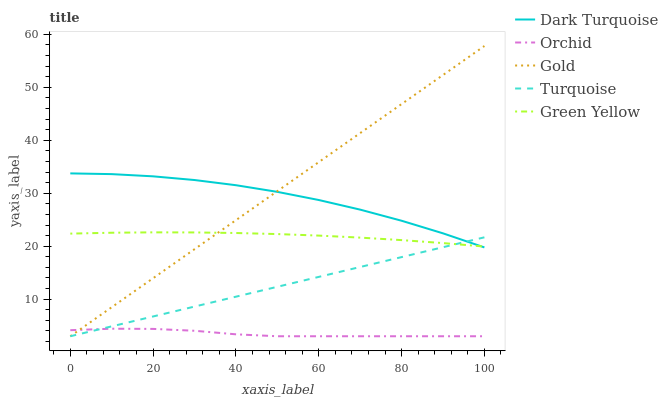Does Orchid have the minimum area under the curve?
Answer yes or no. Yes. Does Gold have the maximum area under the curve?
Answer yes or no. Yes. Does Turquoise have the minimum area under the curve?
Answer yes or no. No. Does Turquoise have the maximum area under the curve?
Answer yes or no. No. Is Turquoise the smoothest?
Answer yes or no. Yes. Is Dark Turquoise the roughest?
Answer yes or no. Yes. Is Green Yellow the smoothest?
Answer yes or no. No. Is Green Yellow the roughest?
Answer yes or no. No. Does Turquoise have the lowest value?
Answer yes or no. Yes. Does Green Yellow have the lowest value?
Answer yes or no. No. Does Gold have the highest value?
Answer yes or no. Yes. Does Turquoise have the highest value?
Answer yes or no. No. Is Orchid less than Green Yellow?
Answer yes or no. Yes. Is Green Yellow greater than Orchid?
Answer yes or no. Yes. Does Dark Turquoise intersect Green Yellow?
Answer yes or no. Yes. Is Dark Turquoise less than Green Yellow?
Answer yes or no. No. Is Dark Turquoise greater than Green Yellow?
Answer yes or no. No. Does Orchid intersect Green Yellow?
Answer yes or no. No. 